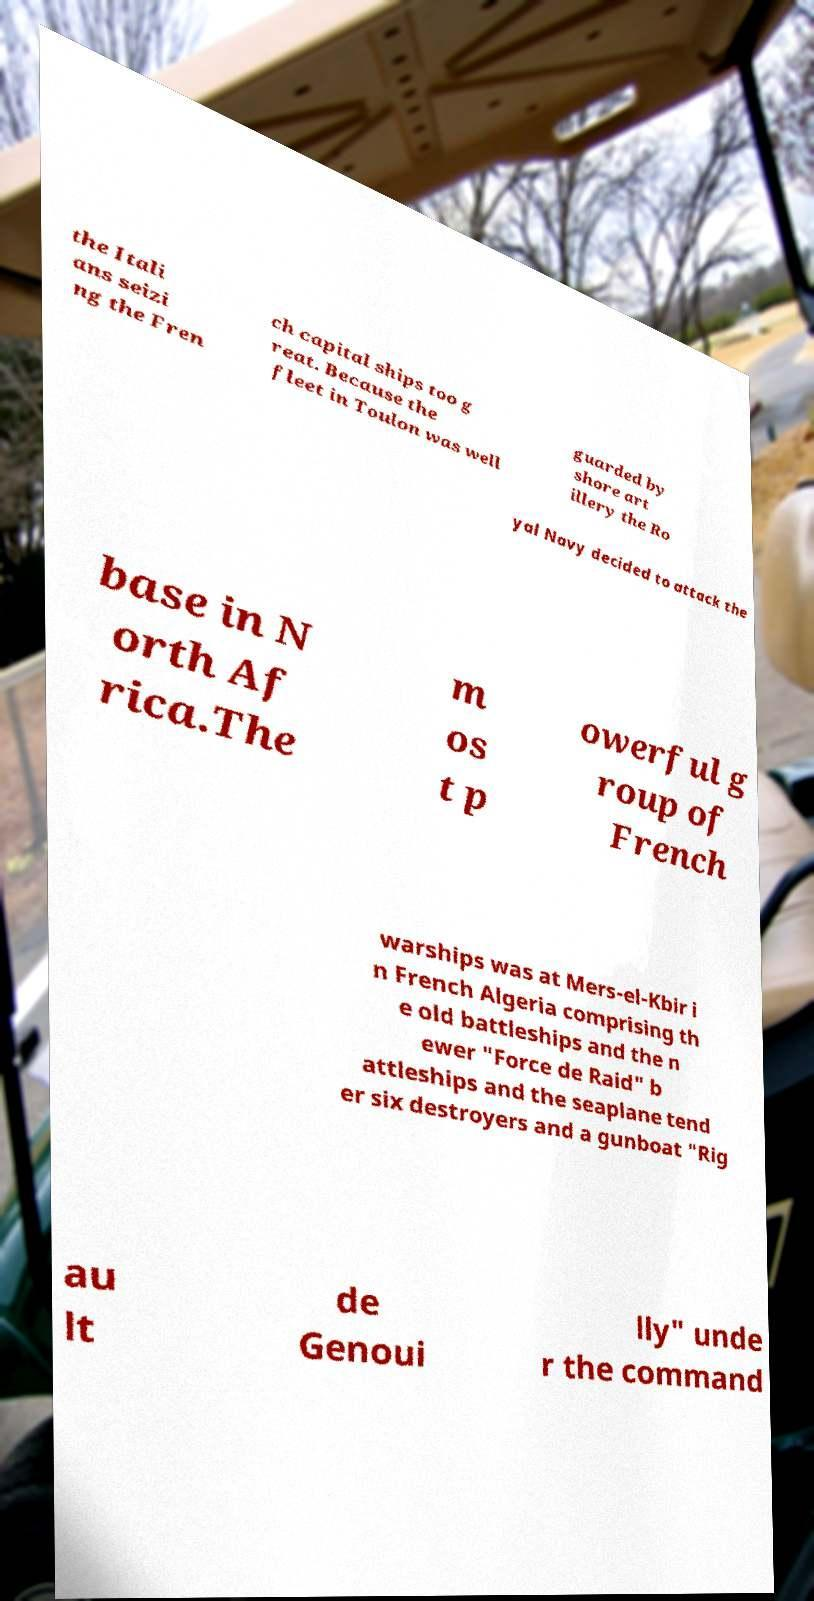Please identify and transcribe the text found in this image. the Itali ans seizi ng the Fren ch capital ships too g reat. Because the fleet in Toulon was well guarded by shore art illery the Ro yal Navy decided to attack the base in N orth Af rica.The m os t p owerful g roup of French warships was at Mers-el-Kbir i n French Algeria comprising th e old battleships and the n ewer "Force de Raid" b attleships and the seaplane tend er six destroyers and a gunboat "Rig au lt de Genoui lly" unde r the command 